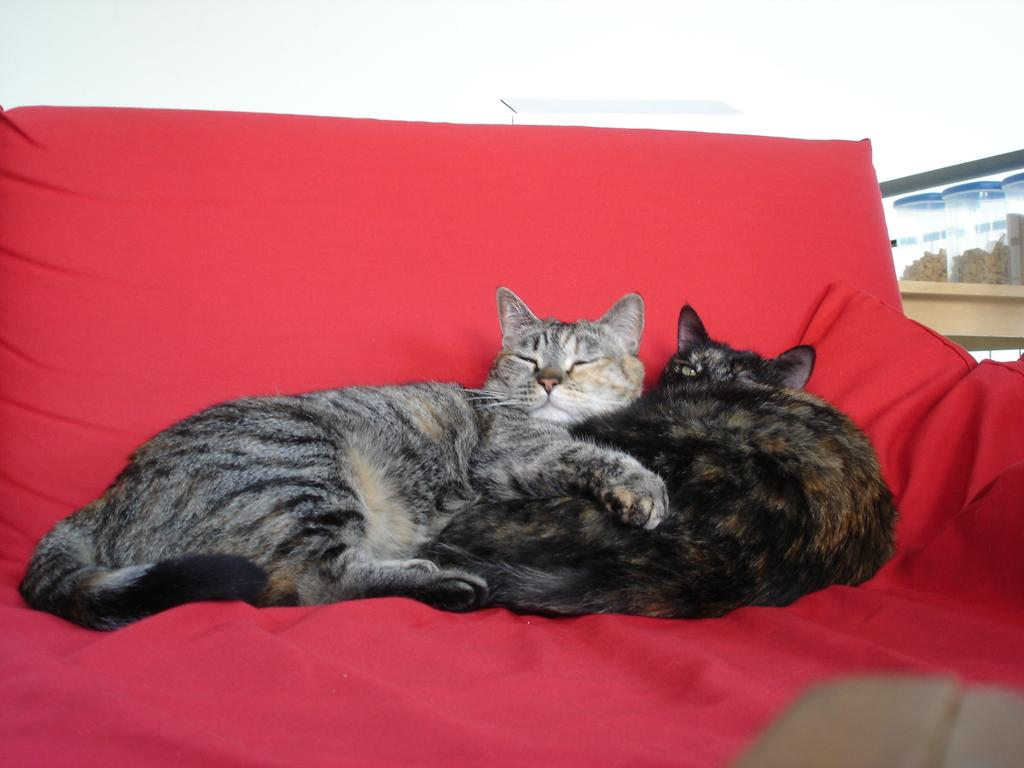How many cats are in the image? There are two cats in the image. Where are the cats located in the image? The cats are sitting on a bed. What color is the cloth visible on the bed? There is a red color cloth visible on the bed. What type of crate is being used to transport the cats in the image? There is no crate present in the image; the cats are sitting on a bed. What type of cord is being used to tie the cats together in the image? There is no cord present in the image, and the cats are not tied together. 